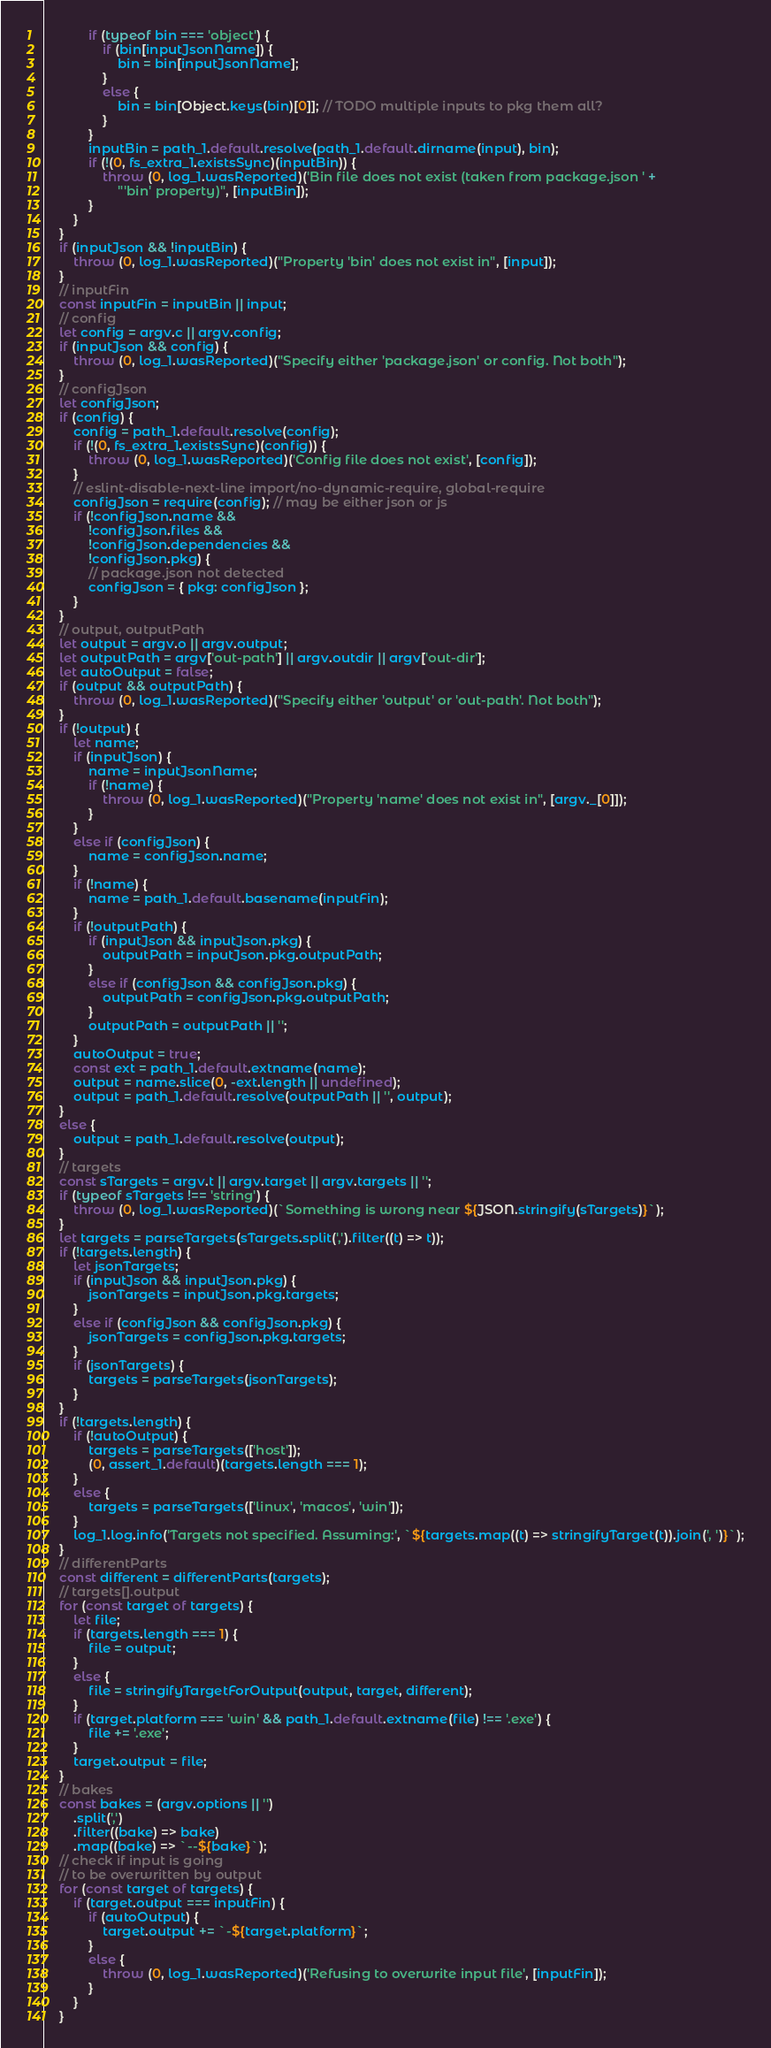Convert code to text. <code><loc_0><loc_0><loc_500><loc_500><_JavaScript_>            if (typeof bin === 'object') {
                if (bin[inputJsonName]) {
                    bin = bin[inputJsonName];
                }
                else {
                    bin = bin[Object.keys(bin)[0]]; // TODO multiple inputs to pkg them all?
                }
            }
            inputBin = path_1.default.resolve(path_1.default.dirname(input), bin);
            if (!(0, fs_extra_1.existsSync)(inputBin)) {
                throw (0, log_1.wasReported)('Bin file does not exist (taken from package.json ' +
                    "'bin' property)", [inputBin]);
            }
        }
    }
    if (inputJson && !inputBin) {
        throw (0, log_1.wasReported)("Property 'bin' does not exist in", [input]);
    }
    // inputFin
    const inputFin = inputBin || input;
    // config
    let config = argv.c || argv.config;
    if (inputJson && config) {
        throw (0, log_1.wasReported)("Specify either 'package.json' or config. Not both");
    }
    // configJson
    let configJson;
    if (config) {
        config = path_1.default.resolve(config);
        if (!(0, fs_extra_1.existsSync)(config)) {
            throw (0, log_1.wasReported)('Config file does not exist', [config]);
        }
        // eslint-disable-next-line import/no-dynamic-require, global-require
        configJson = require(config); // may be either json or js
        if (!configJson.name &&
            !configJson.files &&
            !configJson.dependencies &&
            !configJson.pkg) {
            // package.json not detected
            configJson = { pkg: configJson };
        }
    }
    // output, outputPath
    let output = argv.o || argv.output;
    let outputPath = argv['out-path'] || argv.outdir || argv['out-dir'];
    let autoOutput = false;
    if (output && outputPath) {
        throw (0, log_1.wasReported)("Specify either 'output' or 'out-path'. Not both");
    }
    if (!output) {
        let name;
        if (inputJson) {
            name = inputJsonName;
            if (!name) {
                throw (0, log_1.wasReported)("Property 'name' does not exist in", [argv._[0]]);
            }
        }
        else if (configJson) {
            name = configJson.name;
        }
        if (!name) {
            name = path_1.default.basename(inputFin);
        }
        if (!outputPath) {
            if (inputJson && inputJson.pkg) {
                outputPath = inputJson.pkg.outputPath;
            }
            else if (configJson && configJson.pkg) {
                outputPath = configJson.pkg.outputPath;
            }
            outputPath = outputPath || '';
        }
        autoOutput = true;
        const ext = path_1.default.extname(name);
        output = name.slice(0, -ext.length || undefined);
        output = path_1.default.resolve(outputPath || '', output);
    }
    else {
        output = path_1.default.resolve(output);
    }
    // targets
    const sTargets = argv.t || argv.target || argv.targets || '';
    if (typeof sTargets !== 'string') {
        throw (0, log_1.wasReported)(`Something is wrong near ${JSON.stringify(sTargets)}`);
    }
    let targets = parseTargets(sTargets.split(',').filter((t) => t));
    if (!targets.length) {
        let jsonTargets;
        if (inputJson && inputJson.pkg) {
            jsonTargets = inputJson.pkg.targets;
        }
        else if (configJson && configJson.pkg) {
            jsonTargets = configJson.pkg.targets;
        }
        if (jsonTargets) {
            targets = parseTargets(jsonTargets);
        }
    }
    if (!targets.length) {
        if (!autoOutput) {
            targets = parseTargets(['host']);
            (0, assert_1.default)(targets.length === 1);
        }
        else {
            targets = parseTargets(['linux', 'macos', 'win']);
        }
        log_1.log.info('Targets not specified. Assuming:', `${targets.map((t) => stringifyTarget(t)).join(', ')}`);
    }
    // differentParts
    const different = differentParts(targets);
    // targets[].output
    for (const target of targets) {
        let file;
        if (targets.length === 1) {
            file = output;
        }
        else {
            file = stringifyTargetForOutput(output, target, different);
        }
        if (target.platform === 'win' && path_1.default.extname(file) !== '.exe') {
            file += '.exe';
        }
        target.output = file;
    }
    // bakes
    const bakes = (argv.options || '')
        .split(',')
        .filter((bake) => bake)
        .map((bake) => `--${bake}`);
    // check if input is going
    // to be overwritten by output
    for (const target of targets) {
        if (target.output === inputFin) {
            if (autoOutput) {
                target.output += `-${target.platform}`;
            }
            else {
                throw (0, log_1.wasReported)('Refusing to overwrite input file', [inputFin]);
            }
        }
    }</code> 